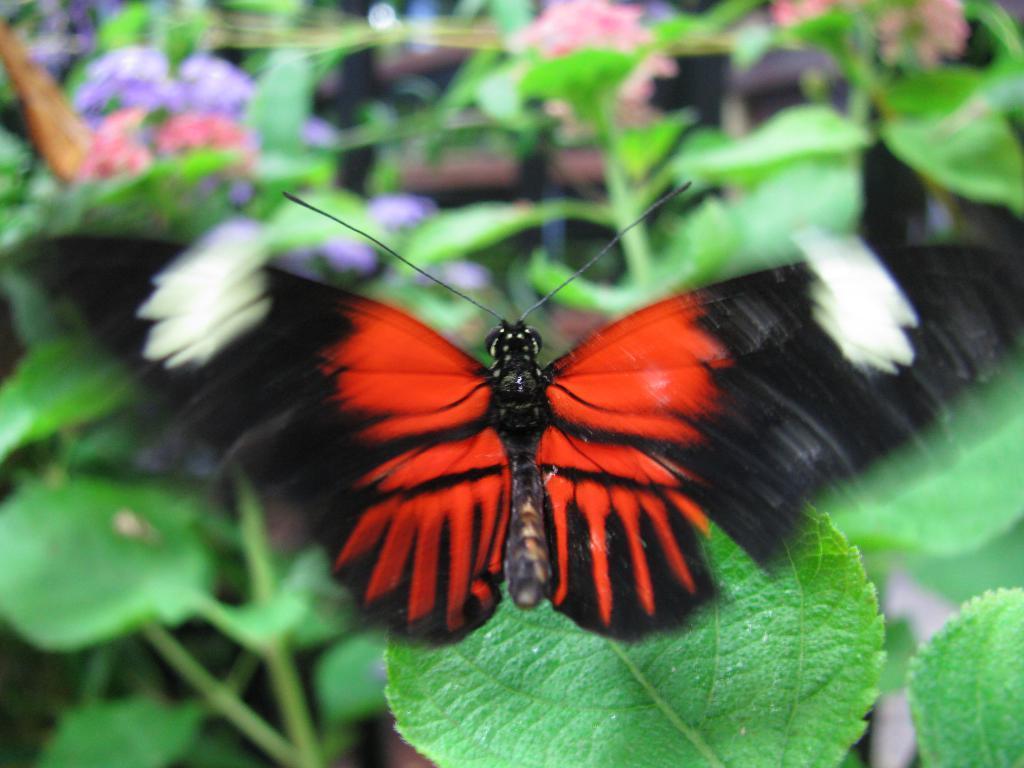Could you give a brief overview of what you see in this image? In the picture we can see a butterfly sitting on a leaf and in the background, we can see many plants which are not clearly visible. 